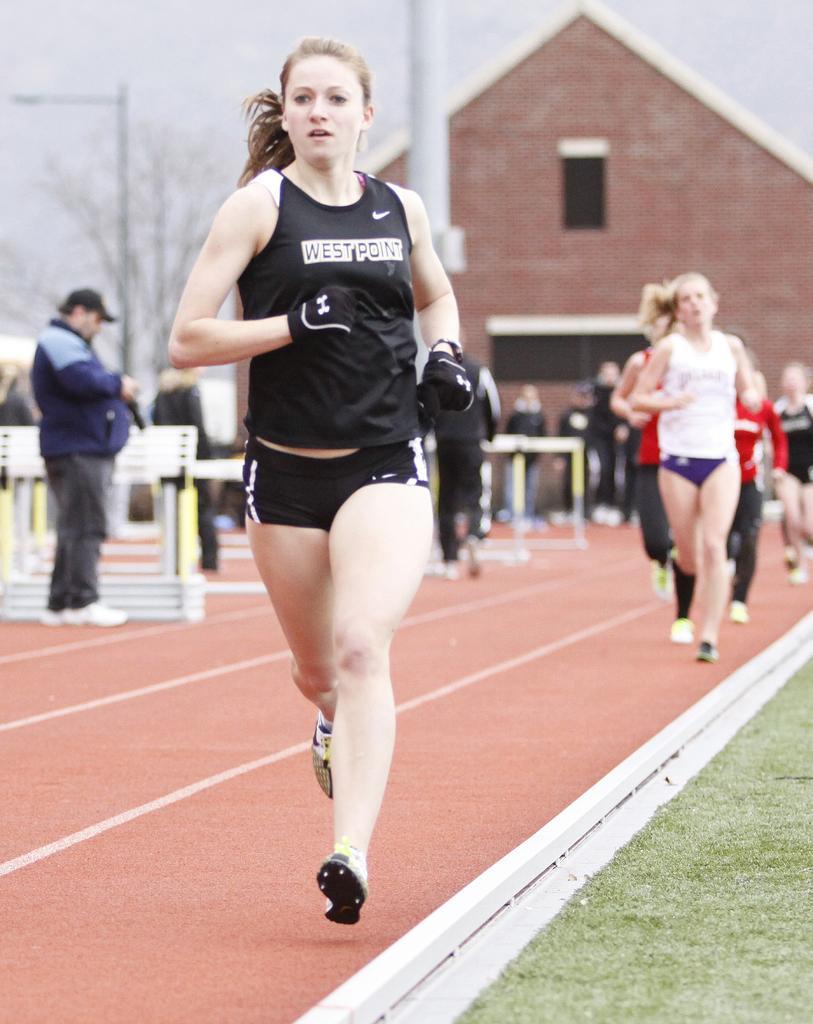How would you summarize this image in a sentence or two? In this image I can see a woman running in a stadium. I can see some other woman behind her towards the right hand side. I can see some people standing behind them. I can see a building, trees and poles. The background is blurred.  